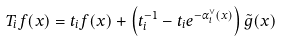<formula> <loc_0><loc_0><loc_500><loc_500>T _ { i } f ( x ) = t _ { i } f ( x ) + \left ( t _ { i } ^ { - 1 } - t _ { i } e ^ { - \alpha ^ { \vee } _ { i } ( x ) } \right ) \tilde { g } ( x )</formula> 